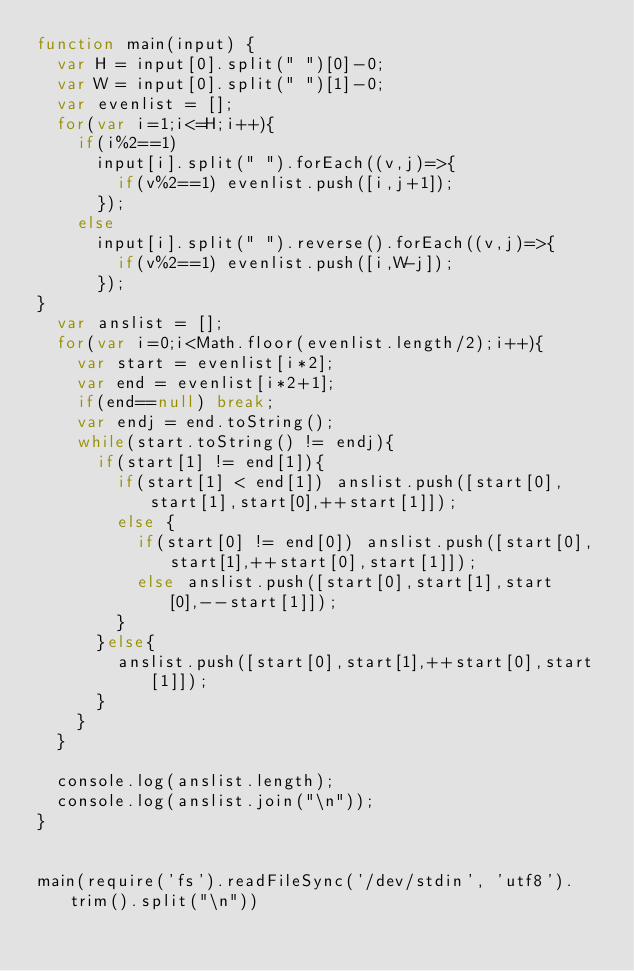<code> <loc_0><loc_0><loc_500><loc_500><_JavaScript_>function main(input) {
  var H = input[0].split(" ")[0]-0;
  var W = input[0].split(" ")[1]-0;
  var evenlist = [];
  for(var i=1;i<=H;i++){
    if(i%2==1)
      input[i].split(" ").forEach((v,j)=>{
        if(v%2==1) evenlist.push([i,j+1]);
      });
    else
      input[i].split(" ").reverse().forEach((v,j)=>{
        if(v%2==1) evenlist.push([i,W-j]);
      });
}
  var anslist = [];
  for(var i=0;i<Math.floor(evenlist.length/2);i++){
    var start = evenlist[i*2];
    var end = evenlist[i*2+1];
    if(end==null) break;
    var endj = end.toString();
    while(start.toString() != endj){
      if(start[1] != end[1]){
        if(start[1] < end[1]) anslist.push([start[0],start[1],start[0],++start[1]]);
        else {
          if(start[0] != end[0]) anslist.push([start[0],start[1],++start[0],start[1]]);
          else anslist.push([start[0],start[1],start[0],--start[1]]);
        }
      }else{
        anslist.push([start[0],start[1],++start[0],start[1]]);
      }
    }
  }

  console.log(anslist.length);
  console.log(anslist.join("\n"));
}


main(require('fs').readFileSync('/dev/stdin', 'utf8').trim().split("\n"))
</code> 